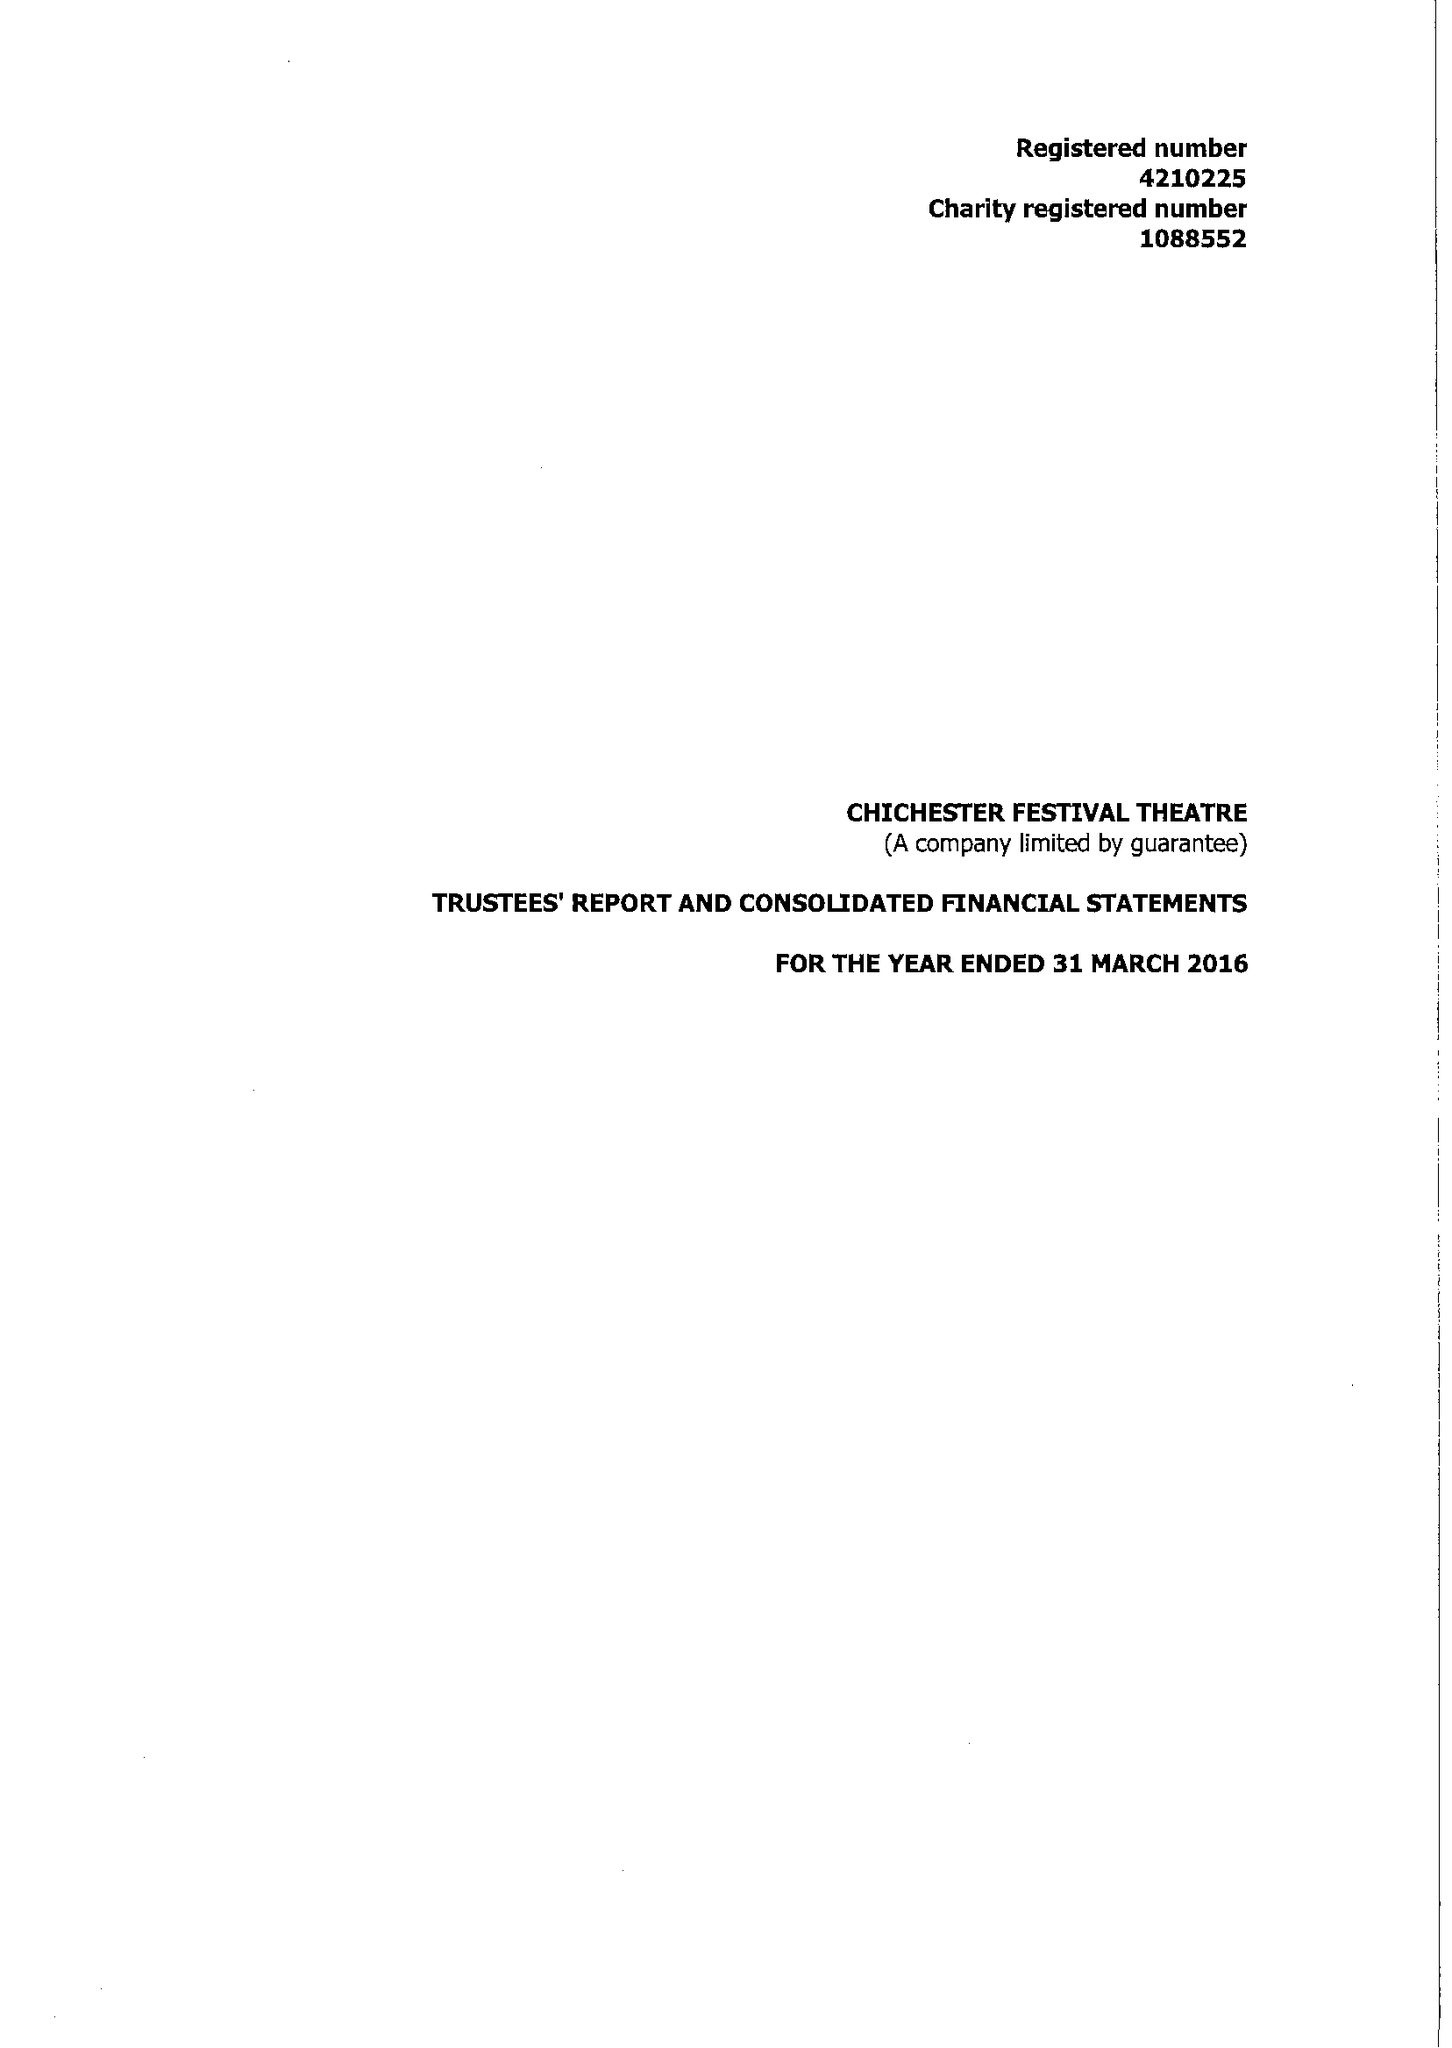What is the value for the charity_name?
Answer the question using a single word or phrase. Chichester Festival Theatre 